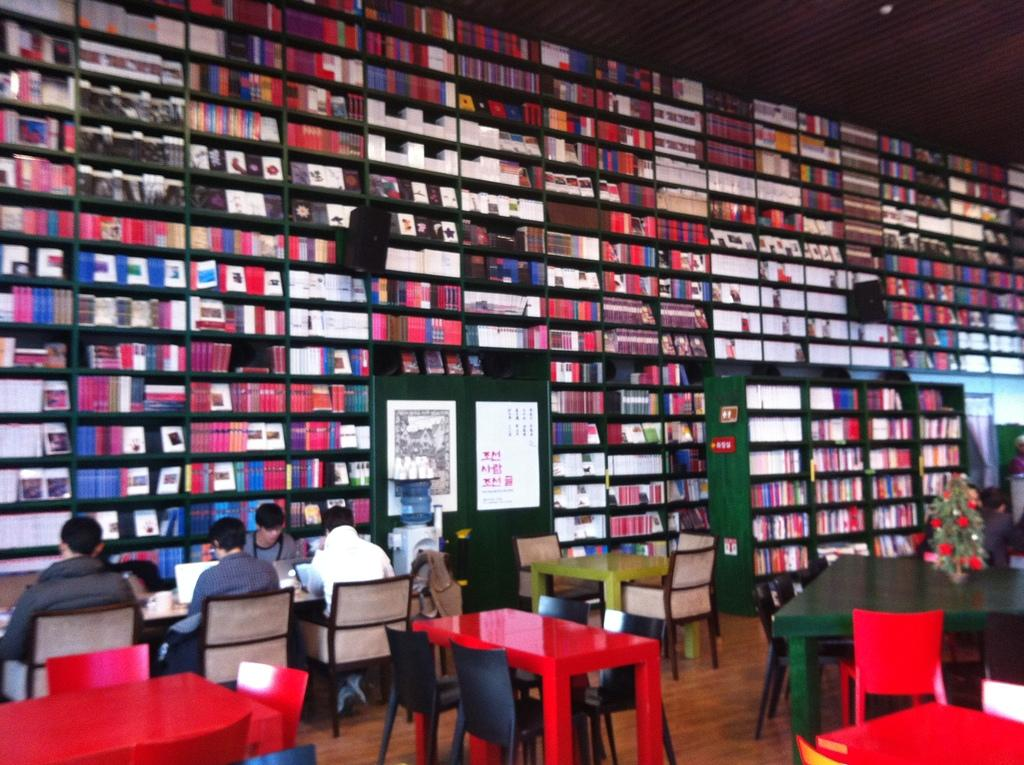What type of place is depicted in the image? The image depicts a library. What furniture is present in the library? There are chairs and tables in the image. What are the people in the image doing? The people are sitting on the chairs and tables, and they are studying. What can be seen in the background of the image? There are books and speakers in the background of the image. What type of cream can be seen on the tables in the image? There is no cream present in the image. 